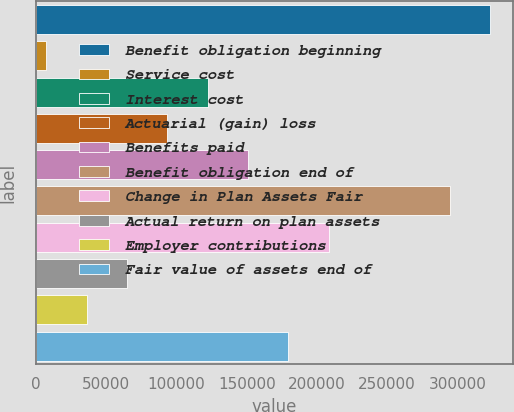Convert chart to OTSL. <chart><loc_0><loc_0><loc_500><loc_500><bar_chart><fcel>Benefit obligation beginning<fcel>Service cost<fcel>Interest cost<fcel>Actuarial (gain) loss<fcel>Benefits paid<fcel>Benefit obligation end of<fcel>Change in Plan Assets Fair<fcel>Actual return on plan assets<fcel>Employer contributions<fcel>Fair value of assets end of<nl><fcel>323483<fcel>7198<fcel>122211<fcel>93457.6<fcel>150964<fcel>294730<fcel>208470<fcel>64704.4<fcel>35951.2<fcel>179717<nl></chart> 